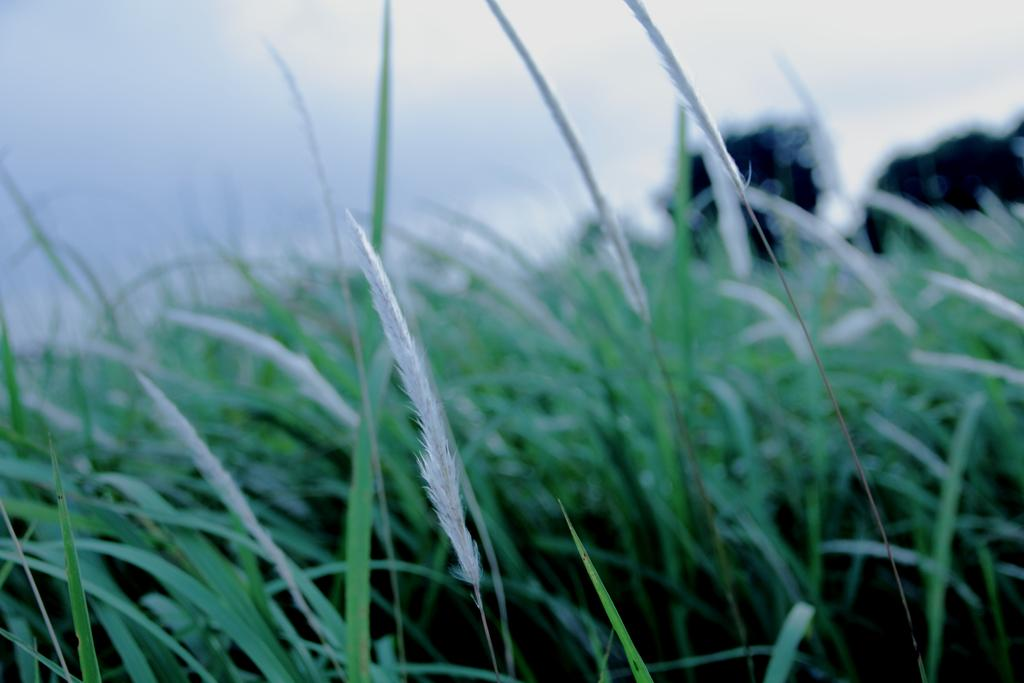What type of vegetation is present in the image? There is green grass in the image. What part of the natural environment is visible in the image? The sky is visible at the top of the image. Can you describe the interaction between the stranger and the vegetable in the image? There is no stranger or vegetable present in the image; it only features green grass and the sky. 